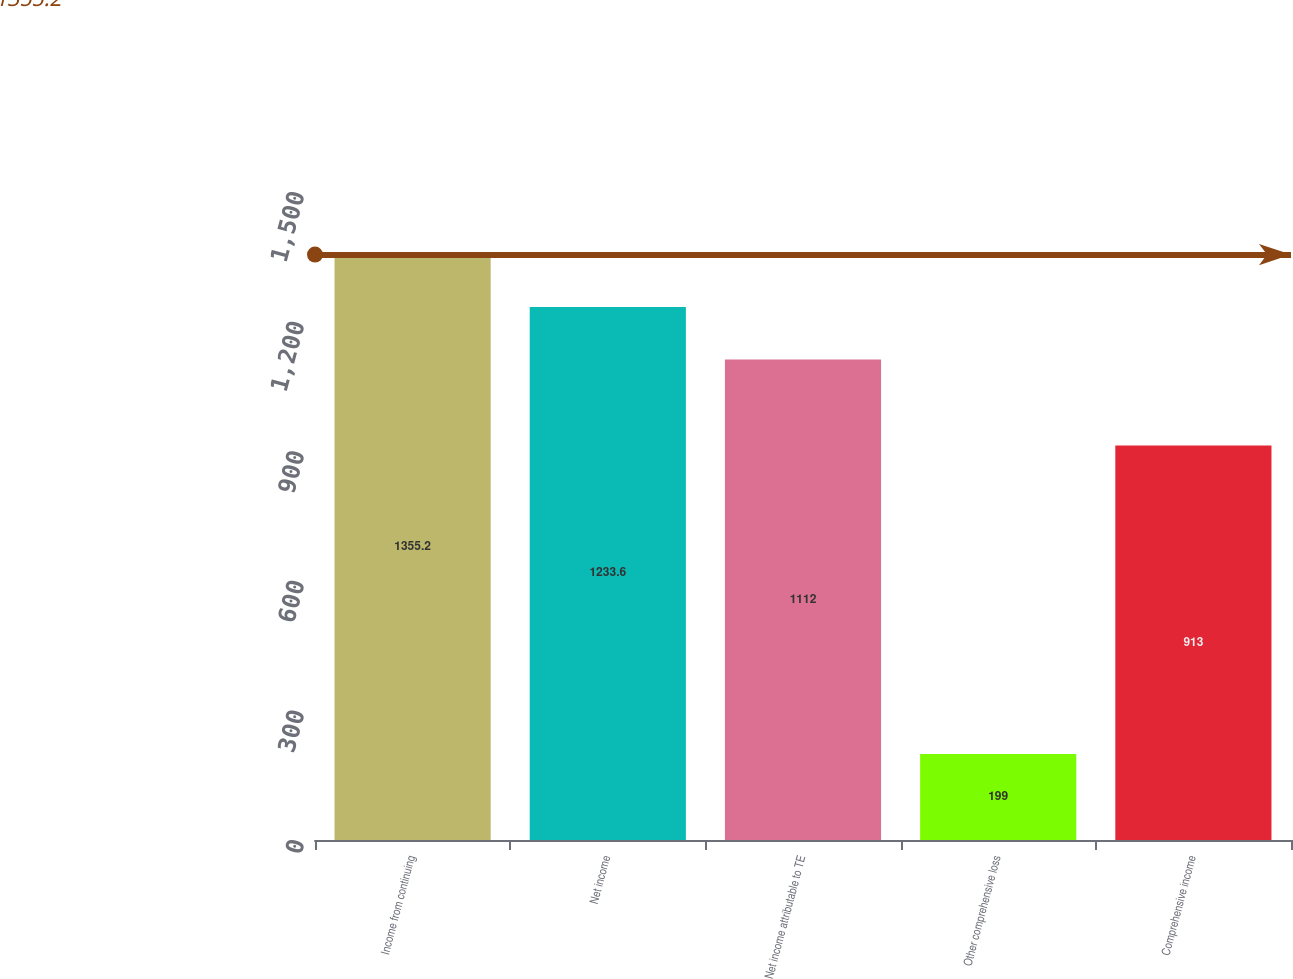Convert chart to OTSL. <chart><loc_0><loc_0><loc_500><loc_500><bar_chart><fcel>Income from continuing<fcel>Net income<fcel>Net income attributable to TE<fcel>Other comprehensive loss<fcel>Comprehensive income<nl><fcel>1355.2<fcel>1233.6<fcel>1112<fcel>199<fcel>913<nl></chart> 